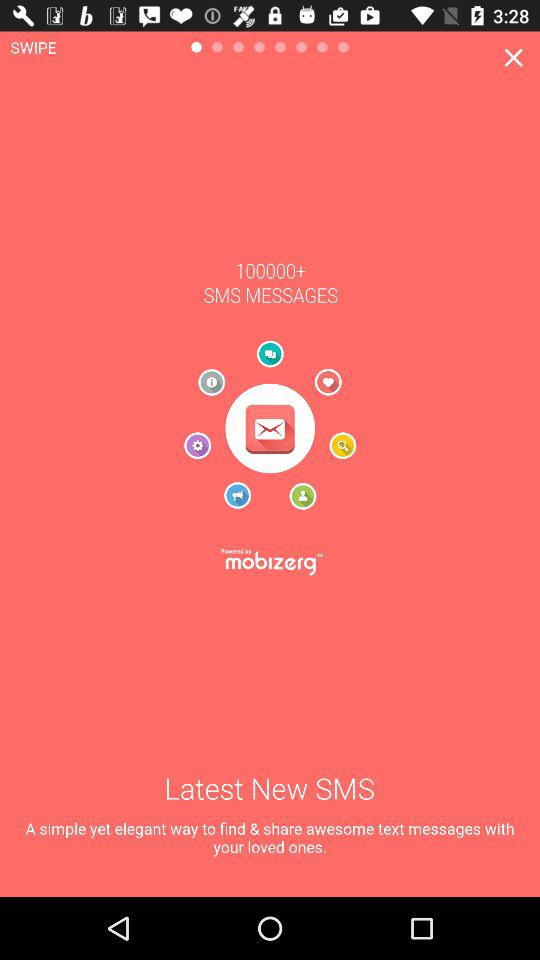What is the app name? The app name is "100000+ SMS MESSAGES". 